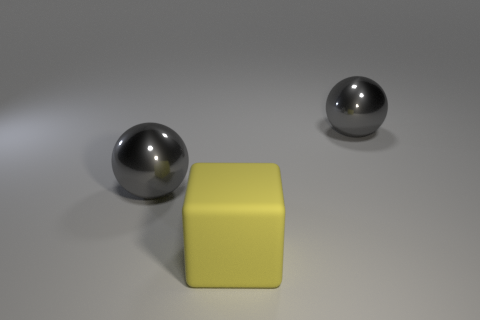Add 3 large matte things. How many objects exist? 6 Subtract all blocks. How many objects are left? 2 Subtract all large matte blocks. Subtract all large gray things. How many objects are left? 0 Add 3 big gray balls. How many big gray balls are left? 5 Add 2 tiny matte cubes. How many tiny matte cubes exist? 2 Subtract 0 brown cubes. How many objects are left? 3 